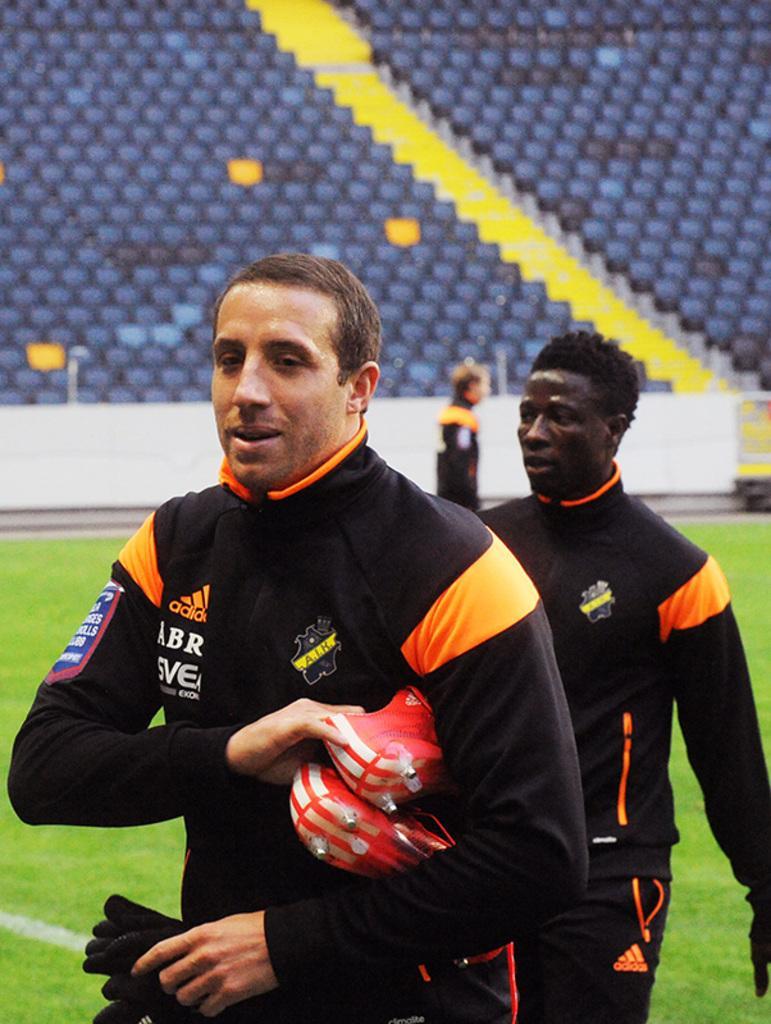Can you describe this image briefly? In the image I can see two people in same dress, among them a person is holding the gloves and to the side there are some chairs on the staircase. 